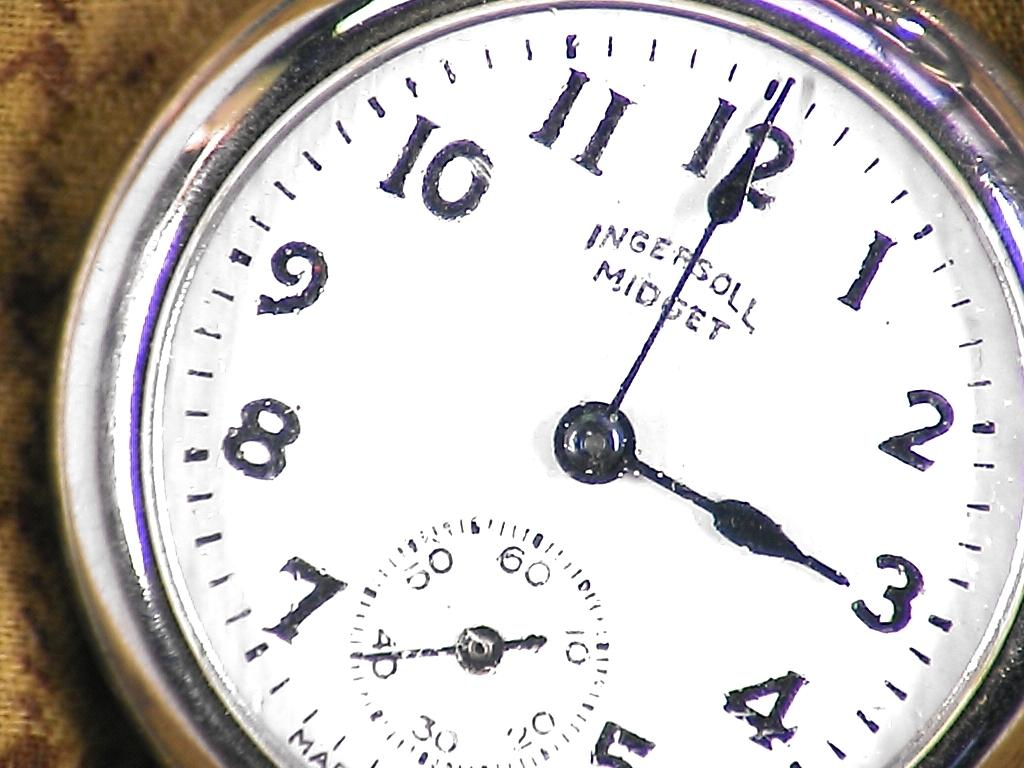<image>
Present a compact description of the photo's key features. Face of a watch that says the word "MIDGET" on it. 